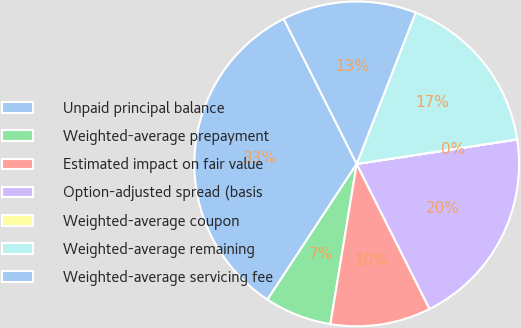Convert chart. <chart><loc_0><loc_0><loc_500><loc_500><pie_chart><fcel>Unpaid principal balance<fcel>Weighted-average prepayment<fcel>Estimated impact on fair value<fcel>Option-adjusted spread (basis<fcel>Weighted-average coupon<fcel>Weighted-average remaining<fcel>Weighted-average servicing fee<nl><fcel>33.32%<fcel>6.67%<fcel>10.0%<fcel>20.0%<fcel>0.01%<fcel>16.67%<fcel>13.33%<nl></chart> 